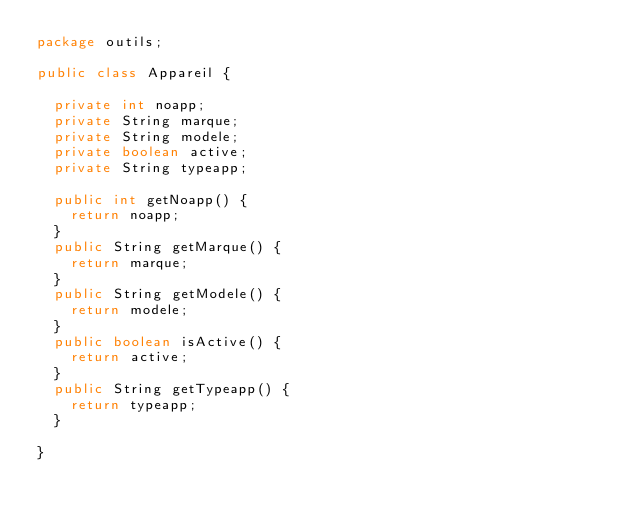Convert code to text. <code><loc_0><loc_0><loc_500><loc_500><_Java_>package outils;

public class Appareil {
	
	private int noapp;
	private String marque;
	private String modele;
	private boolean active;
	private String typeapp;
	
	public int getNoapp() {
		return noapp;
	}
	public String getMarque() {
		return marque;
	}
	public String getModele() {
		return modele;
	}
	public boolean isActive() {
		return active;
	}
	public String getTypeapp() {
		return typeapp;
	}

}
</code> 